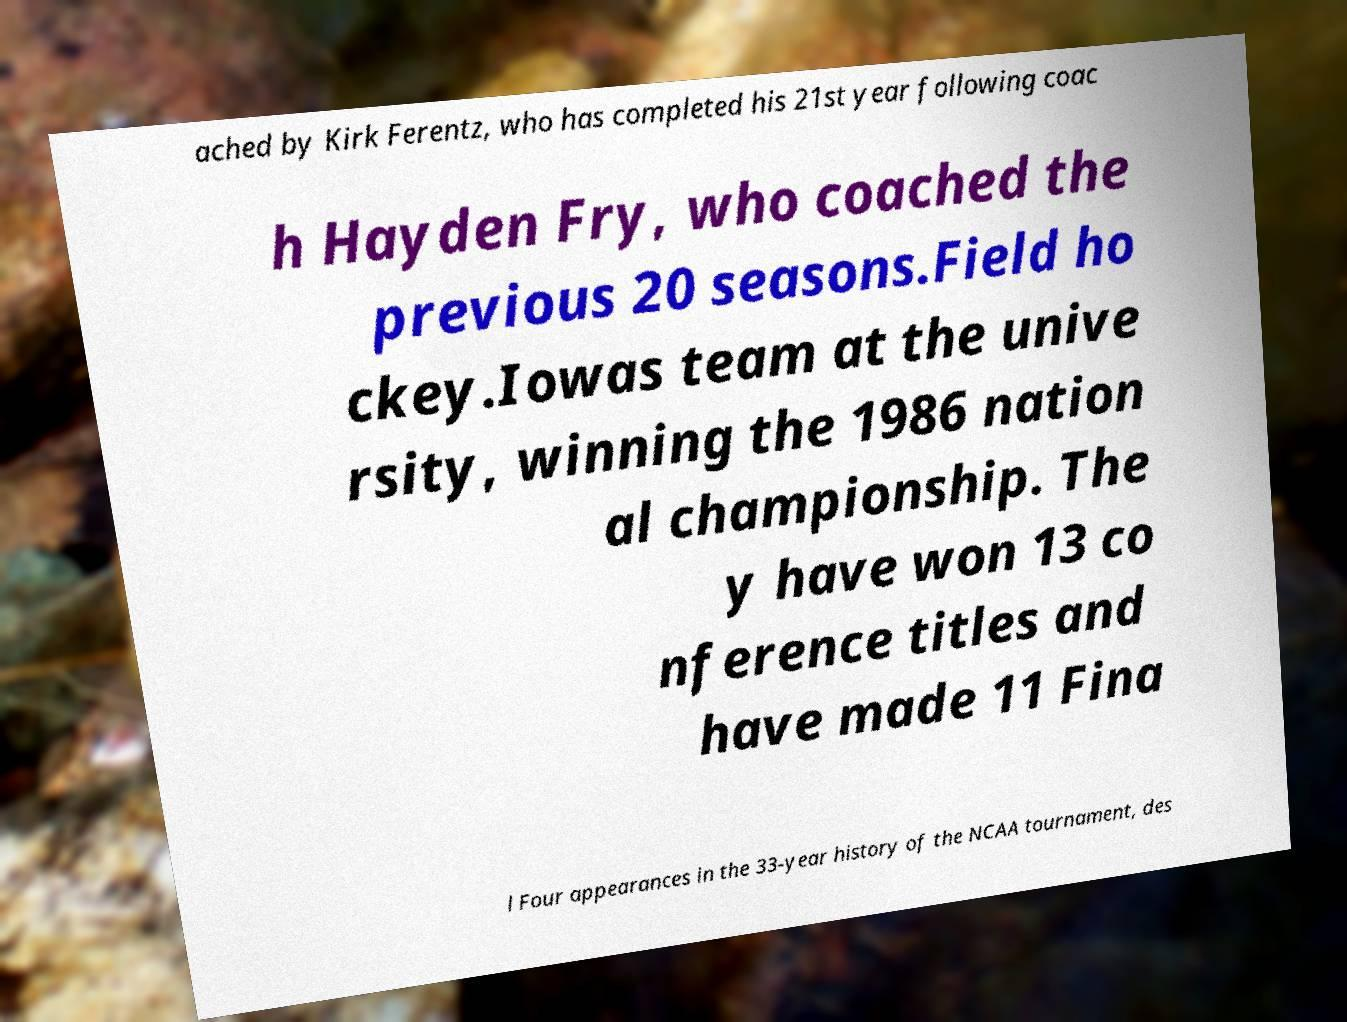Please read and relay the text visible in this image. What does it say? ached by Kirk Ferentz, who has completed his 21st year following coac h Hayden Fry, who coached the previous 20 seasons.Field ho ckey.Iowas team at the unive rsity, winning the 1986 nation al championship. The y have won 13 co nference titles and have made 11 Fina l Four appearances in the 33-year history of the NCAA tournament, des 